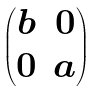Convert formula to latex. <formula><loc_0><loc_0><loc_500><loc_500>\begin{pmatrix} b & 0 \\ 0 & a \end{pmatrix}</formula> 